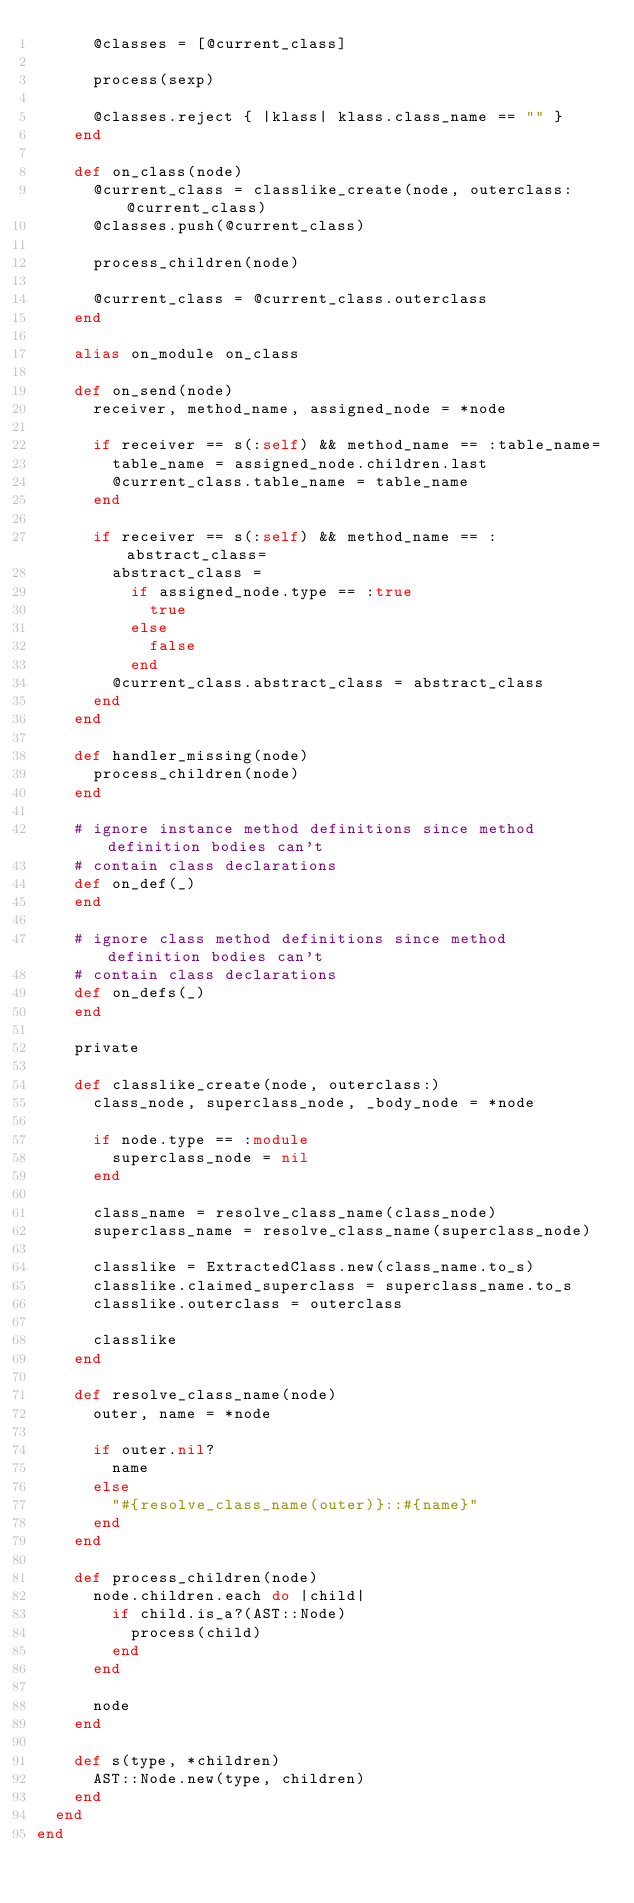Convert code to text. <code><loc_0><loc_0><loc_500><loc_500><_Ruby_>      @classes = [@current_class]

      process(sexp)

      @classes.reject { |klass| klass.class_name == "" }
    end

    def on_class(node)
      @current_class = classlike_create(node, outerclass: @current_class)
      @classes.push(@current_class)

      process_children(node)

      @current_class = @current_class.outerclass
    end

    alias on_module on_class

    def on_send(node)
      receiver, method_name, assigned_node = *node

      if receiver == s(:self) && method_name == :table_name=
        table_name = assigned_node.children.last
        @current_class.table_name = table_name
      end

      if receiver == s(:self) && method_name == :abstract_class=
        abstract_class =
          if assigned_node.type == :true
            true
          else
            false
          end
        @current_class.abstract_class = abstract_class
      end
    end

    def handler_missing(node)
      process_children(node)
    end

    # ignore instance method definitions since method definition bodies can't
    # contain class declarations
    def on_def(_)
    end

    # ignore class method definitions since method definition bodies can't
    # contain class declarations
    def on_defs(_)
    end

    private

    def classlike_create(node, outerclass:)
      class_node, superclass_node, _body_node = *node

      if node.type == :module
        superclass_node = nil
      end

      class_name = resolve_class_name(class_node)
      superclass_name = resolve_class_name(superclass_node)

      classlike = ExtractedClass.new(class_name.to_s)
      classlike.claimed_superclass = superclass_name.to_s
      classlike.outerclass = outerclass

      classlike
    end

    def resolve_class_name(node)
      outer, name = *node

      if outer.nil?
        name
      else
        "#{resolve_class_name(outer)}::#{name}"
      end
    end

    def process_children(node)
      node.children.each do |child|
        if child.is_a?(AST::Node)
          process(child)
        end
      end

      node
    end

    def s(type, *children)
      AST::Node.new(type, children)
    end
  end
end
</code> 